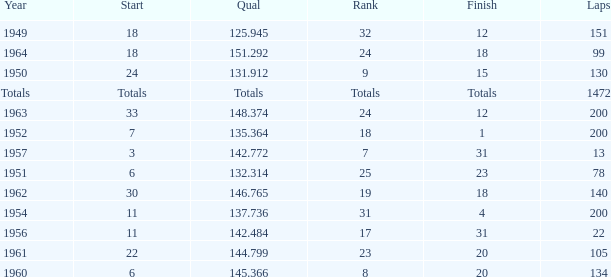Identify the position with 200 circuits and a 14 24.0. 